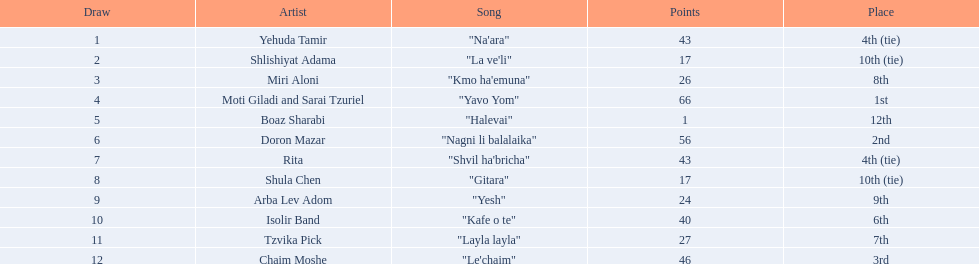Who are all of the artists? Yehuda Tamir, Shlishiyat Adama, Miri Aloni, Moti Giladi and Sarai Tzuriel, Boaz Sharabi, Doron Mazar, Rita, Shula Chen, Arba Lev Adom, Isolir Band, Tzvika Pick, Chaim Moshe. How many points did each score? 43, 17, 26, 66, 1, 56, 43, 17, 24, 40, 27, 46. And which artist had the least amount of points? Boaz Sharabi. 